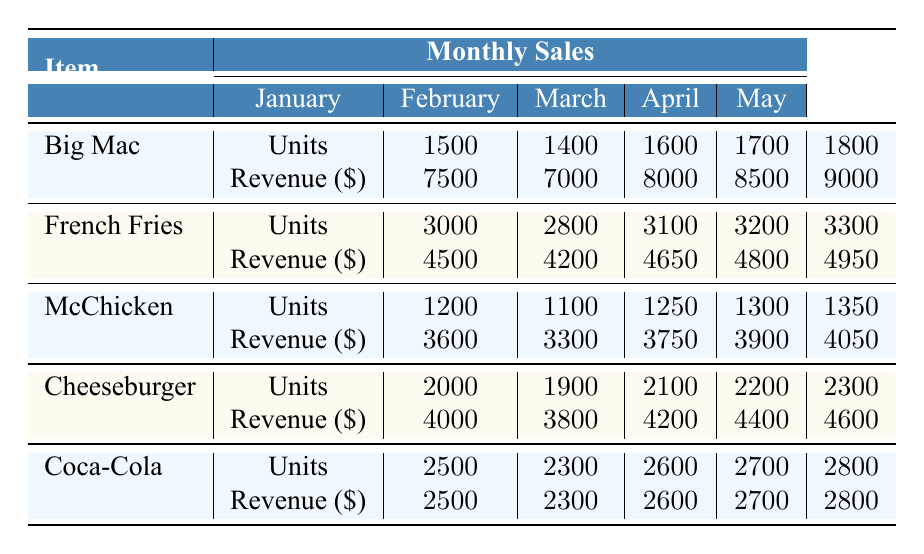What's the total revenue from Big Mac sales in March? In March, the total revenue from Big Mac sales is listed in the table as 8000.
Answer: 8000 Which menu item had the highest sales in units for January? According to the table, French Fries had the highest sales in units for January with 3000 units sold.
Answer: French Fries What is the difference in units sold of the Cheeseburger between February and April? In February, the Cheeseburger sold 1900 units, and in April, it sold 2200 units. The difference is 2200 - 1900 = 300 units.
Answer: 300 Did Coca-Cola see an increase in sales units from January to May? The sales units for Coca-Cola started at 2500 in January and increased to 2800 in May, confirming an increase.
Answer: Yes What is the average number of units sold for McChicken over the five months? The total units sold for McChicken over five months are 1200 + 1100 + 1250 + 1300 + 1350 = 6350. There are 5 months, so the average is 6350 / 5 = 1270.
Answer: 1270 In which month did French Fries experience the largest increase in revenue compared to the previous month? Looking at the revenue for French Fries: January was 4500, February 4200 (decrease), March 4650 (increase of 450 from February), April 4800 (increase of 150), and May 4950 (increase of 150). The largest increase was from March to April, 4800 - 4650 = 150.
Answer: March to April What was the total sales revenue for all items in May? The total sales revenue for May can be calculated by adding the revenues of all items: Big Mac 9000 + French Fries 4950 + McChicken 4050 + Cheeseburger 4600 + Coca-Cola 2800 = 25300.
Answer: 25300 Was the total number of units sold for Cheeseburgers in January higher than that for McChicken in the same month? The number of Cheeseburgers sold in January was 2000, while McChicken sold 1200. Since 2000 is greater than 1200, the statement is true.
Answer: Yes In which month was the total revenue from Coca-Cola the lowest? Referring to the figures, Coca-Cola's revenue was 2500 in January, 2300 in February, 2600 in March, 2700 in April, and 2800 in May. The lowest revenue was in February at 2300.
Answer: February 